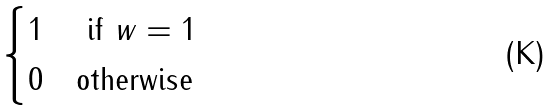<formula> <loc_0><loc_0><loc_500><loc_500>\begin{cases} 1 & \text { if } w = 1 \\ 0 & \text {otherwise} \end{cases}</formula> 